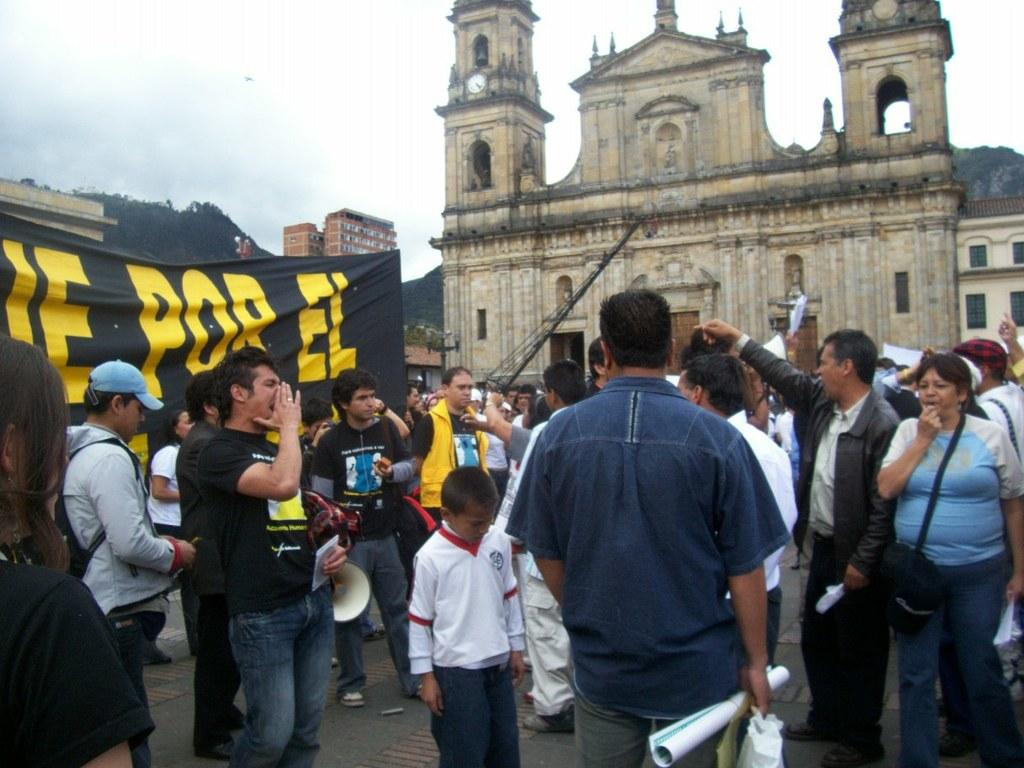What is the main focus of the image? The main focus of the image is the many people in the center. What can be seen in the background of the image? There is a building in the background of the image. Are there any people holding a banner in the image? Yes, there are people holding a black color banner on the left side of the image. What type of mine is depicted in the image? There is no mine present in the image; it features a group of people and a building in the background. What scientific theory is being discussed by the people in the image? There is no indication in the image of a scientific theory being discussed. 